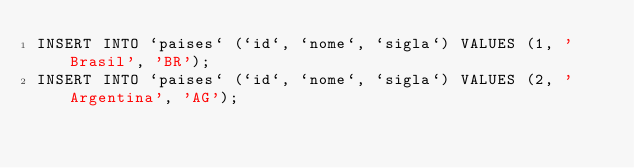<code> <loc_0><loc_0><loc_500><loc_500><_SQL_>INSERT INTO `paises` (`id`, `nome`, `sigla`) VALUES (1, 'Brasil', 'BR');
INSERT INTO `paises` (`id`, `nome`, `sigla`) VALUES (2, 'Argentina', 'AG');</code> 